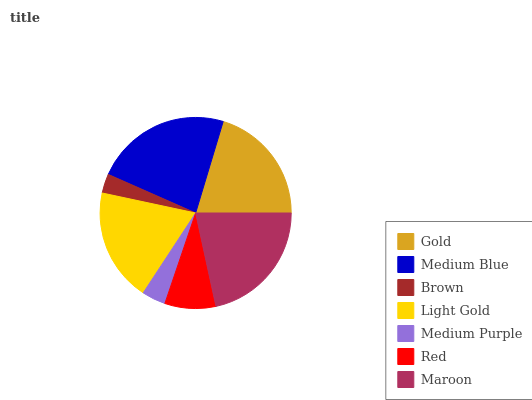Is Brown the minimum?
Answer yes or no. Yes. Is Medium Blue the maximum?
Answer yes or no. Yes. Is Medium Blue the minimum?
Answer yes or no. No. Is Brown the maximum?
Answer yes or no. No. Is Medium Blue greater than Brown?
Answer yes or no. Yes. Is Brown less than Medium Blue?
Answer yes or no. Yes. Is Brown greater than Medium Blue?
Answer yes or no. No. Is Medium Blue less than Brown?
Answer yes or no. No. Is Light Gold the high median?
Answer yes or no. Yes. Is Light Gold the low median?
Answer yes or no. Yes. Is Gold the high median?
Answer yes or no. No. Is Medium Blue the low median?
Answer yes or no. No. 